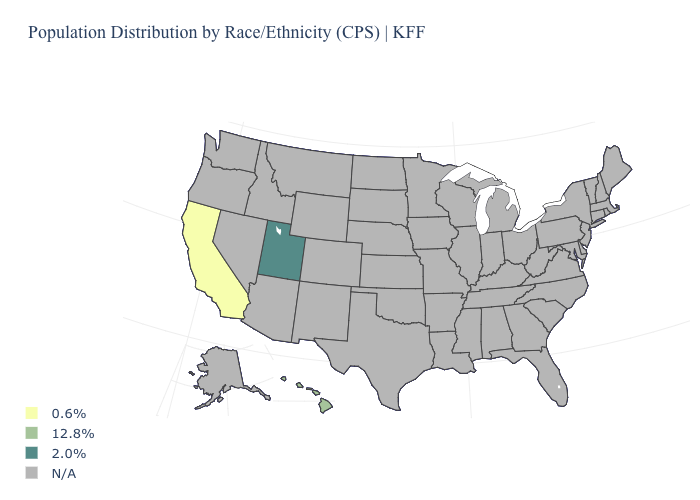What is the value of South Dakota?
Be succinct. N/A. What is the value of Kansas?
Short answer required. N/A. What is the value of Wisconsin?
Concise answer only. N/A. Which states have the lowest value in the West?
Short answer required. California. Is the legend a continuous bar?
Be succinct. No. Is the legend a continuous bar?
Quick response, please. No. Name the states that have a value in the range N/A?
Write a very short answer. Alabama, Alaska, Arizona, Arkansas, Colorado, Connecticut, Delaware, Florida, Georgia, Idaho, Illinois, Indiana, Iowa, Kansas, Kentucky, Louisiana, Maine, Maryland, Massachusetts, Michigan, Minnesota, Mississippi, Missouri, Montana, Nebraska, Nevada, New Hampshire, New Jersey, New Mexico, New York, North Carolina, North Dakota, Ohio, Oklahoma, Oregon, Pennsylvania, Rhode Island, South Carolina, South Dakota, Tennessee, Texas, Vermont, Virginia, Washington, West Virginia, Wisconsin, Wyoming. Does Utah have the lowest value in the West?
Keep it brief. No. Does the map have missing data?
Be succinct. Yes. Does Hawaii have the highest value in the USA?
Keep it brief. No. Does the map have missing data?
Short answer required. Yes. What is the value of Iowa?
Give a very brief answer. N/A. What is the lowest value in the USA?
Answer briefly. 0.6%. What is the value of Virginia?
Keep it brief. N/A. 